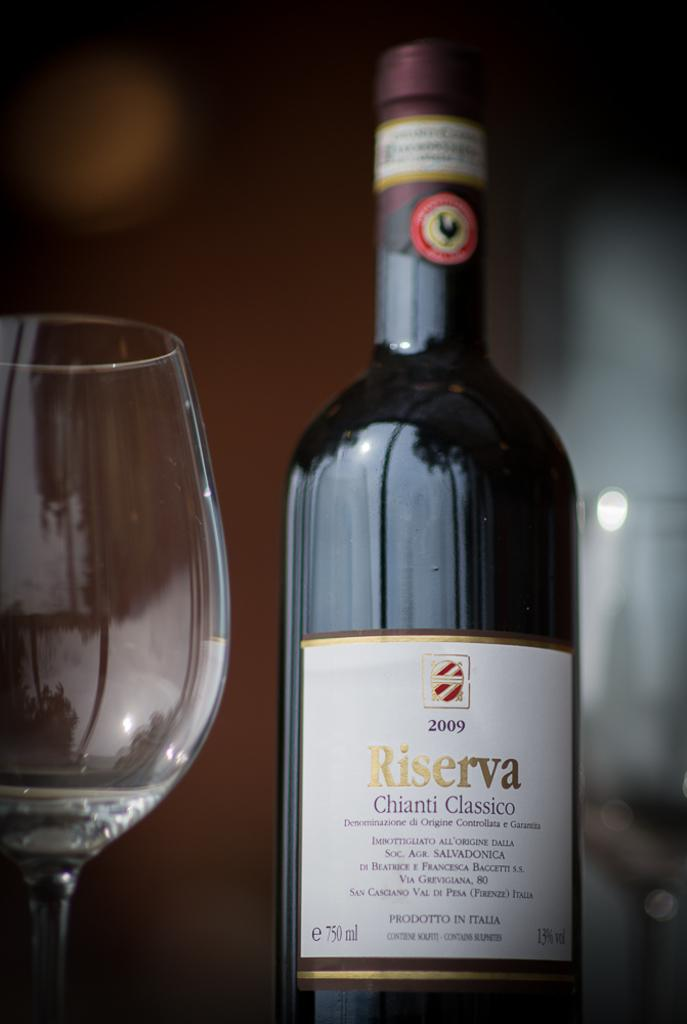Provide a one-sentence caption for the provided image. A bottle of red wine next to a glass, the wine is Riserva Chianti Classico. 